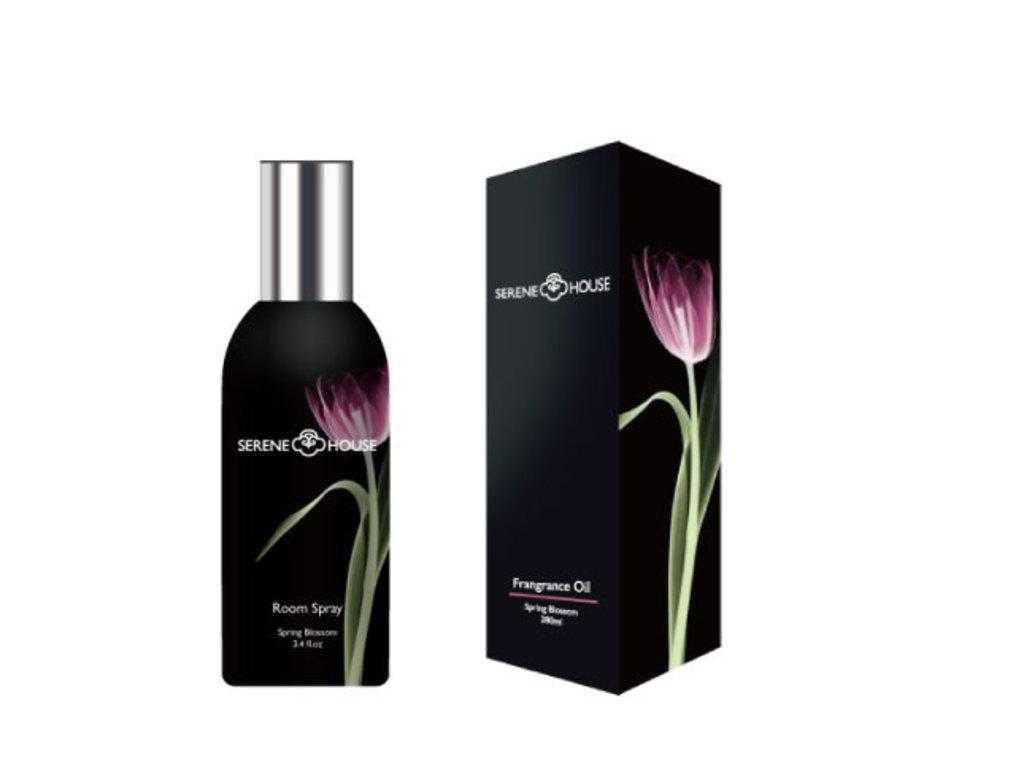Provide a one-sentence caption for the provided image. Serene House Spring Blossom Room Spray bottle stands next to a packaging box with the same colors. 